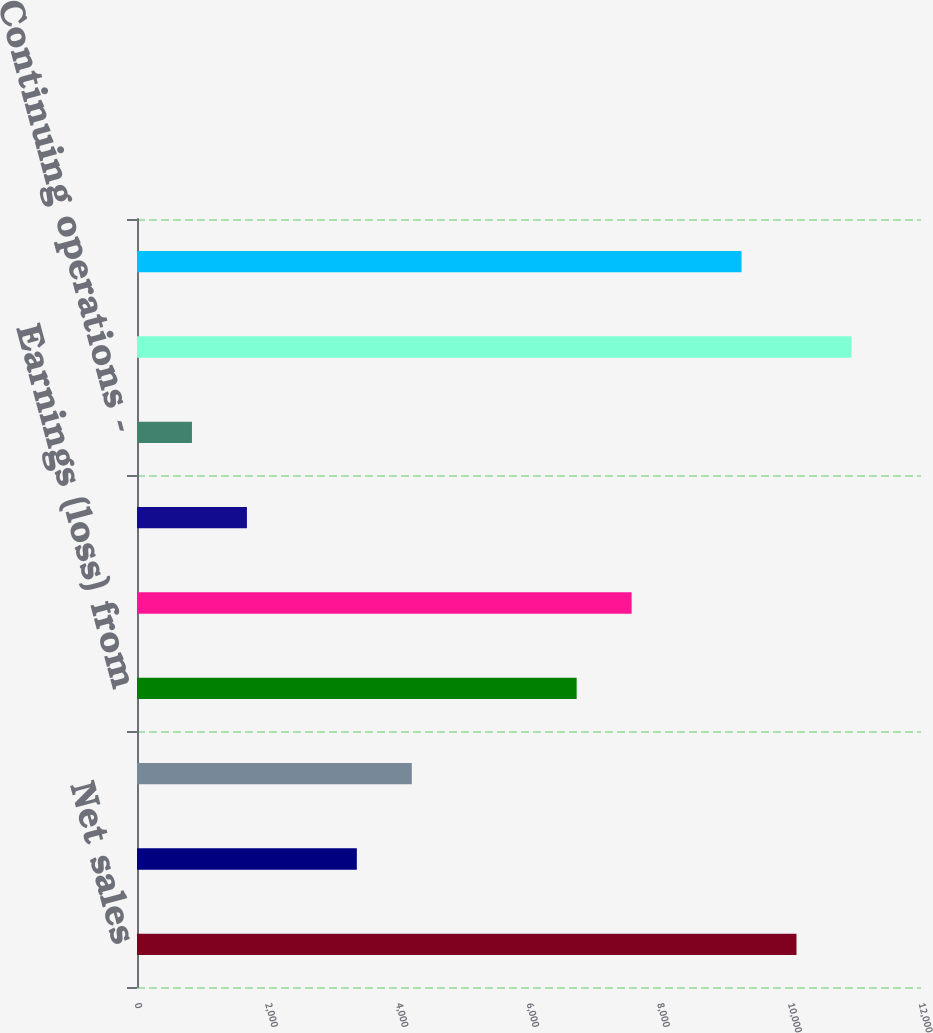Convert chart to OTSL. <chart><loc_0><loc_0><loc_500><loc_500><bar_chart><fcel>Net sales<fcel>Other (charges) gains net<fcel>Operating profit<fcel>Earnings (loss) from<fcel>Net earnings (loss)<fcel>Continuing operations - basic<fcel>Continuing operations -<fcel>Total assets<fcel>Total debt<nl><fcel>10094.3<fcel>3364.88<fcel>4206.06<fcel>6729.6<fcel>7570.78<fcel>1682.52<fcel>841.34<fcel>10935.5<fcel>9253.14<nl></chart> 